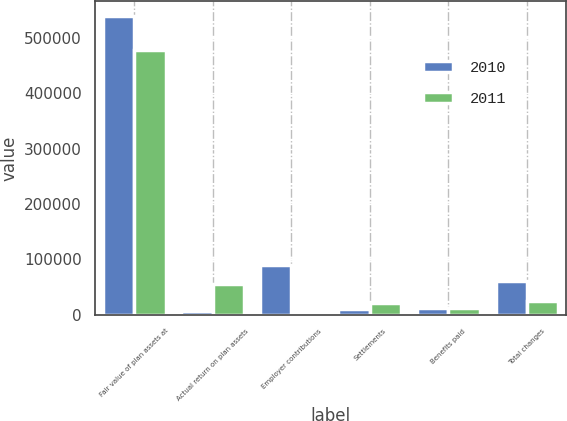<chart> <loc_0><loc_0><loc_500><loc_500><stacked_bar_chart><ecel><fcel>Fair value of plan assets at<fcel>Actual return on plan assets<fcel>Employer contributions<fcel>Settlements<fcel>Benefits paid<fcel>Total changes<nl><fcel>2010<fcel>538970<fcel>6593<fcel>90000<fcel>10631<fcel>12285<fcel>60491<nl><fcel>2011<fcel>478479<fcel>55583<fcel>79<fcel>20911<fcel>11367<fcel>24365<nl></chart> 